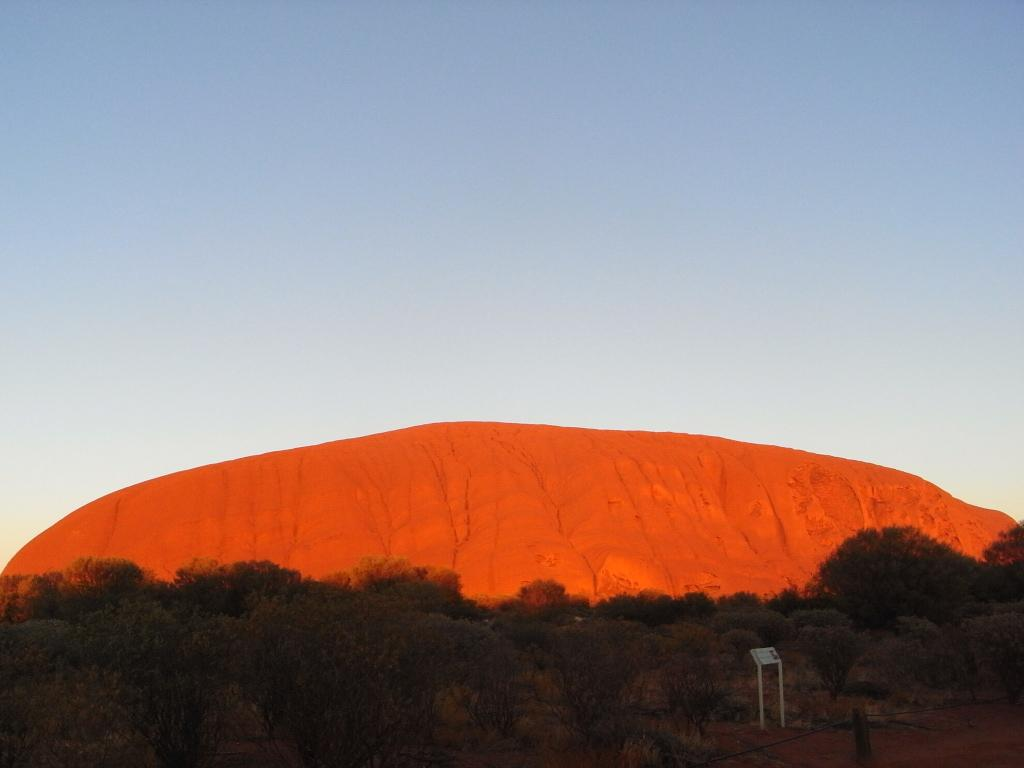What type of vegetation can be seen in the image? There are trees in the image. What structures are present in the image? There are poles in the image. What natural element is visible in the image? There is a rock in the image. What is visible behind the rock in the image? The sky is visible behind the rock. Can you see a hen laying eggs near the rock in the image? There is no hen or eggs present in the image; it features trees, poles, a rock, and the sky. Is there a library visible in the image? There is no library present in the image. 